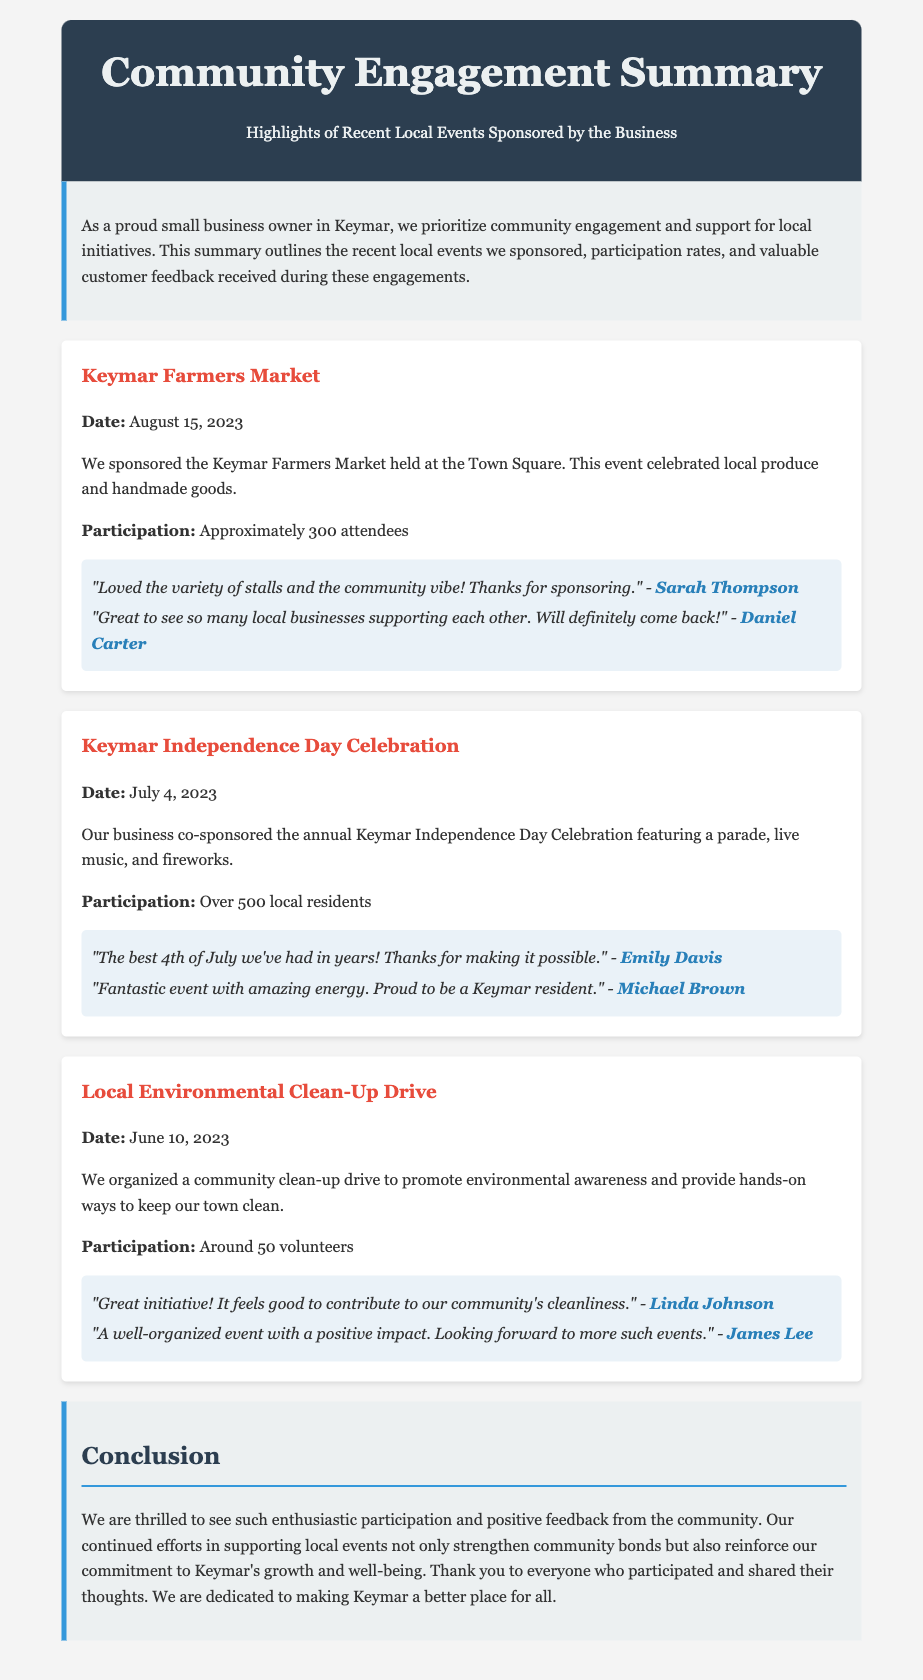What was the date of the Keymar Farmers Market? The date of the Keymar Farmers Market is specifically mentioned in the document.
Answer: August 15, 2023 What was the participation rate for the Keymar Independence Day Celebration? The document states the number of local residents who attended this celebration.
Answer: Over 500 local residents How many volunteers participated in the Local Environmental Clean-Up Drive? The number of volunteers involved in the clean-up drive is detailed in the summary.
Answer: Around 50 volunteers Who provided positive feedback about the Farmers Market? Specific feedback from attendees is shared, along with their names.
Answer: Sarah Thompson, Daniel Carter What type of event was held on July 4, 2023? The document describes the nature of the event that took place on this date.
Answer: Independence Day Celebration What initiative did the business organize for environmental awareness? The summary mentions a specific activity aimed at promoting environmental care.
Answer: Community clean-up drive What was the feedback from Emily Davis about the Independence Day event? Feedback from attendees is included, specifically mentioning a quote from Emily Davis.
Answer: "The best 4th of July we've had in years! Thanks for making it possible." How does the document characterize community feedback? The conclusion section of the document discusses the general sentiment of feedback received.
Answer: Positive feedback 